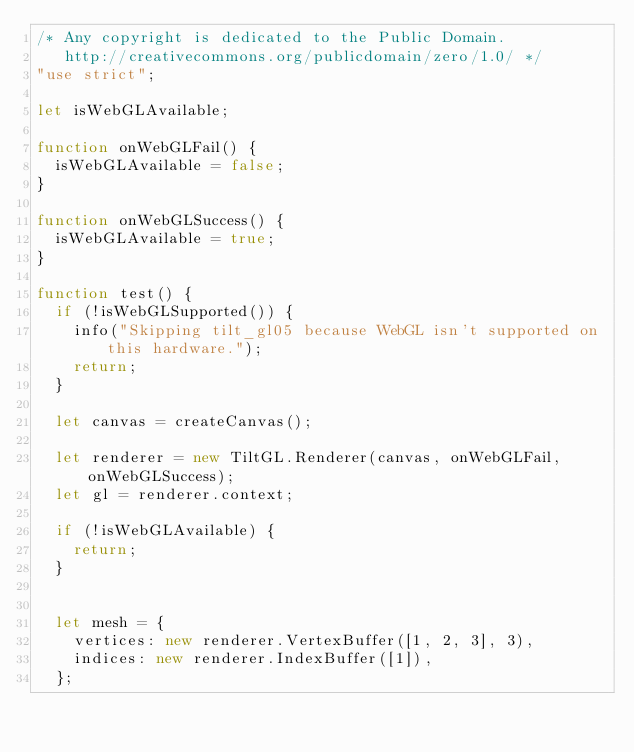<code> <loc_0><loc_0><loc_500><loc_500><_JavaScript_>/* Any copyright is dedicated to the Public Domain.
   http://creativecommons.org/publicdomain/zero/1.0/ */
"use strict";

let isWebGLAvailable;

function onWebGLFail() {
  isWebGLAvailable = false;
}

function onWebGLSuccess() {
  isWebGLAvailable = true;
}

function test() {
  if (!isWebGLSupported()) {
    info("Skipping tilt_gl05 because WebGL isn't supported on this hardware.");
    return;
  }

  let canvas = createCanvas();

  let renderer = new TiltGL.Renderer(canvas, onWebGLFail, onWebGLSuccess);
  let gl = renderer.context;

  if (!isWebGLAvailable) {
    return;
  }


  let mesh = {
    vertices: new renderer.VertexBuffer([1, 2, 3], 3),
    indices: new renderer.IndexBuffer([1]),
  };
</code> 